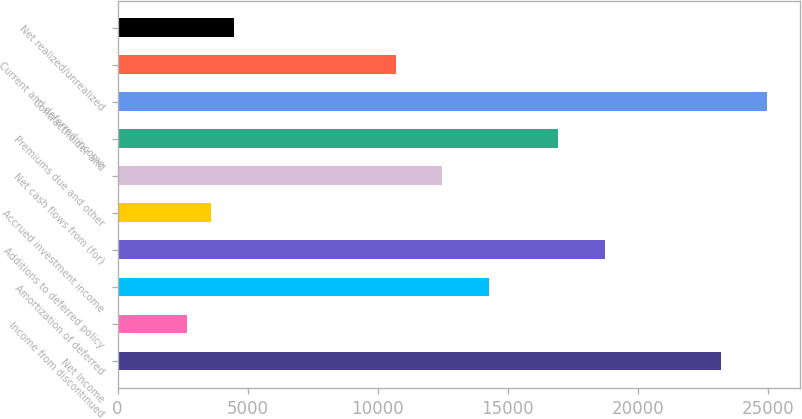Convert chart. <chart><loc_0><loc_0><loc_500><loc_500><bar_chart><fcel>Net Income<fcel>Income from discontinued<fcel>Amortization of deferred<fcel>Additions to deferred policy<fcel>Accrued investment income<fcel>Net cash flows from (for)<fcel>Premiums due and other<fcel>Contractholder and<fcel>Current and deferred income<fcel>Net realized/unrealized<nl><fcel>23191<fcel>2684.64<fcel>14275.2<fcel>18733.1<fcel>3576.22<fcel>12492<fcel>16949.9<fcel>24974.1<fcel>10708.9<fcel>4467.8<nl></chart> 